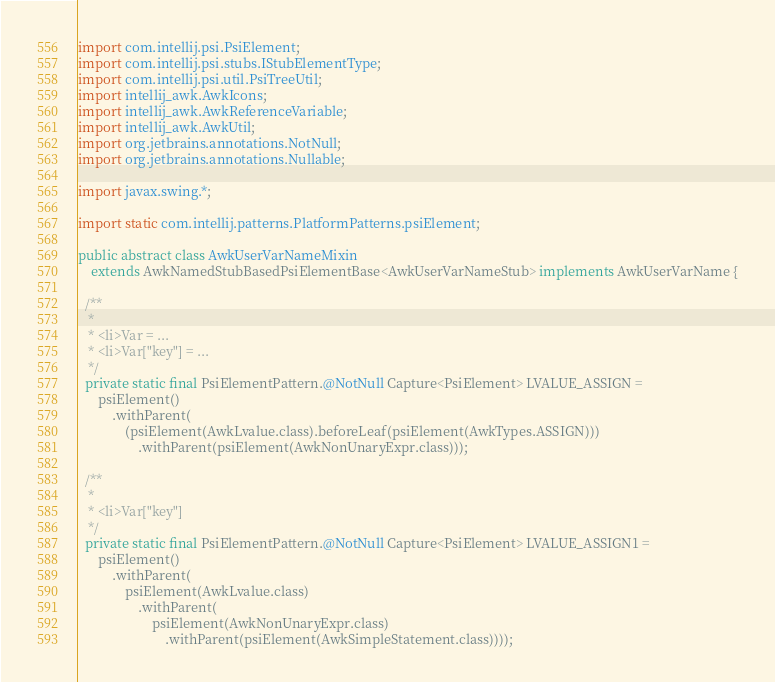Convert code to text. <code><loc_0><loc_0><loc_500><loc_500><_Java_>import com.intellij.psi.PsiElement;
import com.intellij.psi.stubs.IStubElementType;
import com.intellij.psi.util.PsiTreeUtil;
import intellij_awk.AwkIcons;
import intellij_awk.AwkReferenceVariable;
import intellij_awk.AwkUtil;
import org.jetbrains.annotations.NotNull;
import org.jetbrains.annotations.Nullable;

import javax.swing.*;

import static com.intellij.patterns.PlatformPatterns.psiElement;

public abstract class AwkUserVarNameMixin
    extends AwkNamedStubBasedPsiElementBase<AwkUserVarNameStub> implements AwkUserVarName {

  /**
   *
   * <li>Var = ...
   * <li>Var["key"] = ...
   */
  private static final PsiElementPattern.@NotNull Capture<PsiElement> LVALUE_ASSIGN =
      psiElement()
          .withParent(
              (psiElement(AwkLvalue.class).beforeLeaf(psiElement(AwkTypes.ASSIGN)))
                  .withParent(psiElement(AwkNonUnaryExpr.class)));

  /**
   *
   * <li>Var["key"]
   */
  private static final PsiElementPattern.@NotNull Capture<PsiElement> LVALUE_ASSIGN1 =
      psiElement()
          .withParent(
              psiElement(AwkLvalue.class)
                  .withParent(
                      psiElement(AwkNonUnaryExpr.class)
                          .withParent(psiElement(AwkSimpleStatement.class))));
</code> 